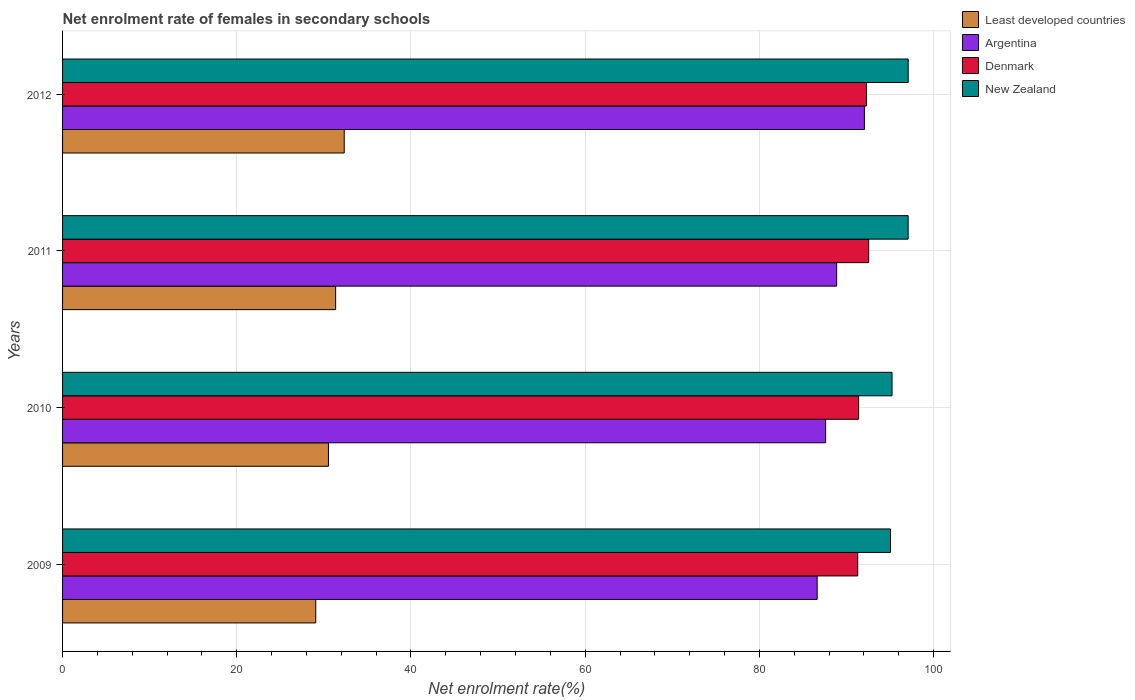How many different coloured bars are there?
Ensure brevity in your answer.  4. How many groups of bars are there?
Offer a very short reply. 4. Are the number of bars per tick equal to the number of legend labels?
Your answer should be very brief. Yes. How many bars are there on the 1st tick from the bottom?
Offer a terse response. 4. What is the label of the 1st group of bars from the top?
Offer a very short reply. 2012. What is the net enrolment rate of females in secondary schools in Least developed countries in 2010?
Give a very brief answer. 30.53. Across all years, what is the maximum net enrolment rate of females in secondary schools in New Zealand?
Your answer should be very brief. 97.09. Across all years, what is the minimum net enrolment rate of females in secondary schools in Argentina?
Give a very brief answer. 86.64. In which year was the net enrolment rate of females in secondary schools in Denmark maximum?
Your response must be concise. 2011. What is the total net enrolment rate of females in secondary schools in Denmark in the graph?
Provide a short and direct response. 367.52. What is the difference between the net enrolment rate of females in secondary schools in Denmark in 2009 and that in 2012?
Your answer should be very brief. -1. What is the difference between the net enrolment rate of females in secondary schools in Least developed countries in 2010 and the net enrolment rate of females in secondary schools in New Zealand in 2011?
Your response must be concise. -66.55. What is the average net enrolment rate of females in secondary schools in Least developed countries per year?
Provide a succinct answer. 30.82. In the year 2012, what is the difference between the net enrolment rate of females in secondary schools in Argentina and net enrolment rate of females in secondary schools in New Zealand?
Your answer should be compact. -5.03. In how many years, is the net enrolment rate of females in secondary schools in Least developed countries greater than 96 %?
Provide a succinct answer. 0. What is the ratio of the net enrolment rate of females in secondary schools in Least developed countries in 2009 to that in 2010?
Your response must be concise. 0.95. Is the difference between the net enrolment rate of females in secondary schools in Argentina in 2009 and 2011 greater than the difference between the net enrolment rate of females in secondary schools in New Zealand in 2009 and 2011?
Your answer should be very brief. No. What is the difference between the highest and the second highest net enrolment rate of females in secondary schools in Argentina?
Provide a succinct answer. 3.19. What is the difference between the highest and the lowest net enrolment rate of females in secondary schools in Denmark?
Provide a short and direct response. 1.26. Is the sum of the net enrolment rate of females in secondary schools in Denmark in 2009 and 2012 greater than the maximum net enrolment rate of females in secondary schools in New Zealand across all years?
Keep it short and to the point. Yes. Is it the case that in every year, the sum of the net enrolment rate of females in secondary schools in Denmark and net enrolment rate of females in secondary schools in Argentina is greater than the sum of net enrolment rate of females in secondary schools in New Zealand and net enrolment rate of females in secondary schools in Least developed countries?
Your answer should be compact. No. What does the 4th bar from the top in 2010 represents?
Keep it short and to the point. Least developed countries. Is it the case that in every year, the sum of the net enrolment rate of females in secondary schools in Denmark and net enrolment rate of females in secondary schools in New Zealand is greater than the net enrolment rate of females in secondary schools in Argentina?
Give a very brief answer. Yes. How many bars are there?
Provide a short and direct response. 16. What is the difference between two consecutive major ticks on the X-axis?
Ensure brevity in your answer.  20. Does the graph contain grids?
Offer a very short reply. Yes. Where does the legend appear in the graph?
Give a very brief answer. Top right. How many legend labels are there?
Provide a short and direct response. 4. What is the title of the graph?
Your answer should be very brief. Net enrolment rate of females in secondary schools. What is the label or title of the X-axis?
Ensure brevity in your answer.  Net enrolment rate(%). What is the Net enrolment rate(%) in Least developed countries in 2009?
Give a very brief answer. 29.07. What is the Net enrolment rate(%) in Argentina in 2009?
Provide a short and direct response. 86.64. What is the Net enrolment rate(%) of Denmark in 2009?
Your answer should be compact. 91.29. What is the Net enrolment rate(%) in New Zealand in 2009?
Your answer should be very brief. 95.05. What is the Net enrolment rate(%) of Least developed countries in 2010?
Offer a terse response. 30.53. What is the Net enrolment rate(%) in Argentina in 2010?
Offer a terse response. 87.61. What is the Net enrolment rate(%) of Denmark in 2010?
Provide a short and direct response. 91.39. What is the Net enrolment rate(%) in New Zealand in 2010?
Provide a succinct answer. 95.23. What is the Net enrolment rate(%) of Least developed countries in 2011?
Your answer should be compact. 31.35. What is the Net enrolment rate(%) of Argentina in 2011?
Make the answer very short. 88.87. What is the Net enrolment rate(%) of Denmark in 2011?
Give a very brief answer. 92.55. What is the Net enrolment rate(%) in New Zealand in 2011?
Offer a terse response. 97.08. What is the Net enrolment rate(%) of Least developed countries in 2012?
Offer a terse response. 32.34. What is the Net enrolment rate(%) of Argentina in 2012?
Your answer should be very brief. 92.06. What is the Net enrolment rate(%) in Denmark in 2012?
Offer a very short reply. 92.29. What is the Net enrolment rate(%) in New Zealand in 2012?
Offer a terse response. 97.09. Across all years, what is the maximum Net enrolment rate(%) of Least developed countries?
Make the answer very short. 32.34. Across all years, what is the maximum Net enrolment rate(%) in Argentina?
Offer a very short reply. 92.06. Across all years, what is the maximum Net enrolment rate(%) of Denmark?
Offer a terse response. 92.55. Across all years, what is the maximum Net enrolment rate(%) of New Zealand?
Give a very brief answer. 97.09. Across all years, what is the minimum Net enrolment rate(%) of Least developed countries?
Provide a short and direct response. 29.07. Across all years, what is the minimum Net enrolment rate(%) of Argentina?
Ensure brevity in your answer.  86.64. Across all years, what is the minimum Net enrolment rate(%) of Denmark?
Provide a short and direct response. 91.29. Across all years, what is the minimum Net enrolment rate(%) in New Zealand?
Give a very brief answer. 95.05. What is the total Net enrolment rate(%) of Least developed countries in the graph?
Keep it short and to the point. 123.28. What is the total Net enrolment rate(%) in Argentina in the graph?
Your response must be concise. 355.18. What is the total Net enrolment rate(%) of Denmark in the graph?
Provide a short and direct response. 367.52. What is the total Net enrolment rate(%) of New Zealand in the graph?
Make the answer very short. 384.45. What is the difference between the Net enrolment rate(%) of Least developed countries in 2009 and that in 2010?
Keep it short and to the point. -1.46. What is the difference between the Net enrolment rate(%) of Argentina in 2009 and that in 2010?
Your answer should be compact. -0.97. What is the difference between the Net enrolment rate(%) of Denmark in 2009 and that in 2010?
Make the answer very short. -0.1. What is the difference between the Net enrolment rate(%) in New Zealand in 2009 and that in 2010?
Offer a very short reply. -0.18. What is the difference between the Net enrolment rate(%) in Least developed countries in 2009 and that in 2011?
Ensure brevity in your answer.  -2.28. What is the difference between the Net enrolment rate(%) of Argentina in 2009 and that in 2011?
Provide a succinct answer. -2.24. What is the difference between the Net enrolment rate(%) of Denmark in 2009 and that in 2011?
Provide a succinct answer. -1.26. What is the difference between the Net enrolment rate(%) of New Zealand in 2009 and that in 2011?
Your response must be concise. -2.03. What is the difference between the Net enrolment rate(%) in Least developed countries in 2009 and that in 2012?
Your answer should be very brief. -3.27. What is the difference between the Net enrolment rate(%) in Argentina in 2009 and that in 2012?
Offer a terse response. -5.42. What is the difference between the Net enrolment rate(%) of Denmark in 2009 and that in 2012?
Give a very brief answer. -1. What is the difference between the Net enrolment rate(%) of New Zealand in 2009 and that in 2012?
Ensure brevity in your answer.  -2.03. What is the difference between the Net enrolment rate(%) in Least developed countries in 2010 and that in 2011?
Make the answer very short. -0.83. What is the difference between the Net enrolment rate(%) in Argentina in 2010 and that in 2011?
Offer a terse response. -1.26. What is the difference between the Net enrolment rate(%) in Denmark in 2010 and that in 2011?
Your answer should be compact. -1.16. What is the difference between the Net enrolment rate(%) of New Zealand in 2010 and that in 2011?
Provide a short and direct response. -1.85. What is the difference between the Net enrolment rate(%) in Least developed countries in 2010 and that in 2012?
Your response must be concise. -1.81. What is the difference between the Net enrolment rate(%) in Argentina in 2010 and that in 2012?
Give a very brief answer. -4.45. What is the difference between the Net enrolment rate(%) in Denmark in 2010 and that in 2012?
Provide a succinct answer. -0.9. What is the difference between the Net enrolment rate(%) in New Zealand in 2010 and that in 2012?
Ensure brevity in your answer.  -1.85. What is the difference between the Net enrolment rate(%) in Least developed countries in 2011 and that in 2012?
Offer a terse response. -0.99. What is the difference between the Net enrolment rate(%) of Argentina in 2011 and that in 2012?
Make the answer very short. -3.19. What is the difference between the Net enrolment rate(%) of Denmark in 2011 and that in 2012?
Provide a succinct answer. 0.26. What is the difference between the Net enrolment rate(%) in New Zealand in 2011 and that in 2012?
Offer a terse response. -0.01. What is the difference between the Net enrolment rate(%) in Least developed countries in 2009 and the Net enrolment rate(%) in Argentina in 2010?
Your answer should be very brief. -58.54. What is the difference between the Net enrolment rate(%) in Least developed countries in 2009 and the Net enrolment rate(%) in Denmark in 2010?
Ensure brevity in your answer.  -62.32. What is the difference between the Net enrolment rate(%) in Least developed countries in 2009 and the Net enrolment rate(%) in New Zealand in 2010?
Provide a short and direct response. -66.16. What is the difference between the Net enrolment rate(%) of Argentina in 2009 and the Net enrolment rate(%) of Denmark in 2010?
Provide a short and direct response. -4.76. What is the difference between the Net enrolment rate(%) in Argentina in 2009 and the Net enrolment rate(%) in New Zealand in 2010?
Give a very brief answer. -8.6. What is the difference between the Net enrolment rate(%) of Denmark in 2009 and the Net enrolment rate(%) of New Zealand in 2010?
Offer a terse response. -3.94. What is the difference between the Net enrolment rate(%) in Least developed countries in 2009 and the Net enrolment rate(%) in Argentina in 2011?
Provide a succinct answer. -59.8. What is the difference between the Net enrolment rate(%) in Least developed countries in 2009 and the Net enrolment rate(%) in Denmark in 2011?
Offer a terse response. -63.48. What is the difference between the Net enrolment rate(%) in Least developed countries in 2009 and the Net enrolment rate(%) in New Zealand in 2011?
Provide a succinct answer. -68.01. What is the difference between the Net enrolment rate(%) in Argentina in 2009 and the Net enrolment rate(%) in Denmark in 2011?
Offer a very short reply. -5.91. What is the difference between the Net enrolment rate(%) in Argentina in 2009 and the Net enrolment rate(%) in New Zealand in 2011?
Provide a succinct answer. -10.44. What is the difference between the Net enrolment rate(%) in Denmark in 2009 and the Net enrolment rate(%) in New Zealand in 2011?
Provide a short and direct response. -5.79. What is the difference between the Net enrolment rate(%) of Least developed countries in 2009 and the Net enrolment rate(%) of Argentina in 2012?
Your answer should be very brief. -62.99. What is the difference between the Net enrolment rate(%) in Least developed countries in 2009 and the Net enrolment rate(%) in Denmark in 2012?
Make the answer very short. -63.22. What is the difference between the Net enrolment rate(%) in Least developed countries in 2009 and the Net enrolment rate(%) in New Zealand in 2012?
Provide a short and direct response. -68.02. What is the difference between the Net enrolment rate(%) of Argentina in 2009 and the Net enrolment rate(%) of Denmark in 2012?
Make the answer very short. -5.66. What is the difference between the Net enrolment rate(%) of Argentina in 2009 and the Net enrolment rate(%) of New Zealand in 2012?
Give a very brief answer. -10.45. What is the difference between the Net enrolment rate(%) in Denmark in 2009 and the Net enrolment rate(%) in New Zealand in 2012?
Ensure brevity in your answer.  -5.8. What is the difference between the Net enrolment rate(%) of Least developed countries in 2010 and the Net enrolment rate(%) of Argentina in 2011?
Provide a succinct answer. -58.35. What is the difference between the Net enrolment rate(%) of Least developed countries in 2010 and the Net enrolment rate(%) of Denmark in 2011?
Provide a short and direct response. -62.02. What is the difference between the Net enrolment rate(%) of Least developed countries in 2010 and the Net enrolment rate(%) of New Zealand in 2011?
Your response must be concise. -66.56. What is the difference between the Net enrolment rate(%) of Argentina in 2010 and the Net enrolment rate(%) of Denmark in 2011?
Keep it short and to the point. -4.94. What is the difference between the Net enrolment rate(%) of Argentina in 2010 and the Net enrolment rate(%) of New Zealand in 2011?
Provide a succinct answer. -9.47. What is the difference between the Net enrolment rate(%) of Denmark in 2010 and the Net enrolment rate(%) of New Zealand in 2011?
Your answer should be compact. -5.69. What is the difference between the Net enrolment rate(%) in Least developed countries in 2010 and the Net enrolment rate(%) in Argentina in 2012?
Make the answer very short. -61.53. What is the difference between the Net enrolment rate(%) of Least developed countries in 2010 and the Net enrolment rate(%) of Denmark in 2012?
Offer a terse response. -61.77. What is the difference between the Net enrolment rate(%) in Least developed countries in 2010 and the Net enrolment rate(%) in New Zealand in 2012?
Make the answer very short. -66.56. What is the difference between the Net enrolment rate(%) of Argentina in 2010 and the Net enrolment rate(%) of Denmark in 2012?
Provide a succinct answer. -4.68. What is the difference between the Net enrolment rate(%) of Argentina in 2010 and the Net enrolment rate(%) of New Zealand in 2012?
Provide a succinct answer. -9.48. What is the difference between the Net enrolment rate(%) in Denmark in 2010 and the Net enrolment rate(%) in New Zealand in 2012?
Offer a terse response. -5.69. What is the difference between the Net enrolment rate(%) in Least developed countries in 2011 and the Net enrolment rate(%) in Argentina in 2012?
Your response must be concise. -60.71. What is the difference between the Net enrolment rate(%) in Least developed countries in 2011 and the Net enrolment rate(%) in Denmark in 2012?
Your answer should be very brief. -60.94. What is the difference between the Net enrolment rate(%) in Least developed countries in 2011 and the Net enrolment rate(%) in New Zealand in 2012?
Offer a terse response. -65.74. What is the difference between the Net enrolment rate(%) in Argentina in 2011 and the Net enrolment rate(%) in Denmark in 2012?
Provide a short and direct response. -3.42. What is the difference between the Net enrolment rate(%) in Argentina in 2011 and the Net enrolment rate(%) in New Zealand in 2012?
Offer a very short reply. -8.21. What is the difference between the Net enrolment rate(%) of Denmark in 2011 and the Net enrolment rate(%) of New Zealand in 2012?
Offer a very short reply. -4.54. What is the average Net enrolment rate(%) of Least developed countries per year?
Your answer should be compact. 30.82. What is the average Net enrolment rate(%) in Argentina per year?
Offer a terse response. 88.79. What is the average Net enrolment rate(%) of Denmark per year?
Your answer should be compact. 91.88. What is the average Net enrolment rate(%) in New Zealand per year?
Offer a terse response. 96.11. In the year 2009, what is the difference between the Net enrolment rate(%) of Least developed countries and Net enrolment rate(%) of Argentina?
Your answer should be compact. -57.57. In the year 2009, what is the difference between the Net enrolment rate(%) in Least developed countries and Net enrolment rate(%) in Denmark?
Provide a succinct answer. -62.22. In the year 2009, what is the difference between the Net enrolment rate(%) of Least developed countries and Net enrolment rate(%) of New Zealand?
Provide a succinct answer. -65.98. In the year 2009, what is the difference between the Net enrolment rate(%) of Argentina and Net enrolment rate(%) of Denmark?
Give a very brief answer. -4.65. In the year 2009, what is the difference between the Net enrolment rate(%) in Argentina and Net enrolment rate(%) in New Zealand?
Make the answer very short. -8.42. In the year 2009, what is the difference between the Net enrolment rate(%) in Denmark and Net enrolment rate(%) in New Zealand?
Provide a succinct answer. -3.76. In the year 2010, what is the difference between the Net enrolment rate(%) of Least developed countries and Net enrolment rate(%) of Argentina?
Make the answer very short. -57.08. In the year 2010, what is the difference between the Net enrolment rate(%) of Least developed countries and Net enrolment rate(%) of Denmark?
Keep it short and to the point. -60.87. In the year 2010, what is the difference between the Net enrolment rate(%) in Least developed countries and Net enrolment rate(%) in New Zealand?
Your answer should be very brief. -64.71. In the year 2010, what is the difference between the Net enrolment rate(%) of Argentina and Net enrolment rate(%) of Denmark?
Your response must be concise. -3.78. In the year 2010, what is the difference between the Net enrolment rate(%) of Argentina and Net enrolment rate(%) of New Zealand?
Your answer should be very brief. -7.62. In the year 2010, what is the difference between the Net enrolment rate(%) of Denmark and Net enrolment rate(%) of New Zealand?
Your answer should be compact. -3.84. In the year 2011, what is the difference between the Net enrolment rate(%) of Least developed countries and Net enrolment rate(%) of Argentina?
Offer a very short reply. -57.52. In the year 2011, what is the difference between the Net enrolment rate(%) in Least developed countries and Net enrolment rate(%) in Denmark?
Give a very brief answer. -61.2. In the year 2011, what is the difference between the Net enrolment rate(%) in Least developed countries and Net enrolment rate(%) in New Zealand?
Provide a short and direct response. -65.73. In the year 2011, what is the difference between the Net enrolment rate(%) of Argentina and Net enrolment rate(%) of Denmark?
Ensure brevity in your answer.  -3.68. In the year 2011, what is the difference between the Net enrolment rate(%) in Argentina and Net enrolment rate(%) in New Zealand?
Your response must be concise. -8.21. In the year 2011, what is the difference between the Net enrolment rate(%) in Denmark and Net enrolment rate(%) in New Zealand?
Offer a terse response. -4.53. In the year 2012, what is the difference between the Net enrolment rate(%) of Least developed countries and Net enrolment rate(%) of Argentina?
Give a very brief answer. -59.72. In the year 2012, what is the difference between the Net enrolment rate(%) in Least developed countries and Net enrolment rate(%) in Denmark?
Provide a succinct answer. -59.95. In the year 2012, what is the difference between the Net enrolment rate(%) of Least developed countries and Net enrolment rate(%) of New Zealand?
Keep it short and to the point. -64.75. In the year 2012, what is the difference between the Net enrolment rate(%) of Argentina and Net enrolment rate(%) of Denmark?
Provide a succinct answer. -0.23. In the year 2012, what is the difference between the Net enrolment rate(%) of Argentina and Net enrolment rate(%) of New Zealand?
Keep it short and to the point. -5.03. In the year 2012, what is the difference between the Net enrolment rate(%) of Denmark and Net enrolment rate(%) of New Zealand?
Your response must be concise. -4.8. What is the ratio of the Net enrolment rate(%) in Least developed countries in 2009 to that in 2010?
Provide a succinct answer. 0.95. What is the ratio of the Net enrolment rate(%) in Argentina in 2009 to that in 2010?
Provide a succinct answer. 0.99. What is the ratio of the Net enrolment rate(%) of Denmark in 2009 to that in 2010?
Make the answer very short. 1. What is the ratio of the Net enrolment rate(%) in Least developed countries in 2009 to that in 2011?
Offer a very short reply. 0.93. What is the ratio of the Net enrolment rate(%) in Argentina in 2009 to that in 2011?
Keep it short and to the point. 0.97. What is the ratio of the Net enrolment rate(%) of Denmark in 2009 to that in 2011?
Ensure brevity in your answer.  0.99. What is the ratio of the Net enrolment rate(%) in New Zealand in 2009 to that in 2011?
Keep it short and to the point. 0.98. What is the ratio of the Net enrolment rate(%) in Least developed countries in 2009 to that in 2012?
Provide a short and direct response. 0.9. What is the ratio of the Net enrolment rate(%) of Argentina in 2009 to that in 2012?
Make the answer very short. 0.94. What is the ratio of the Net enrolment rate(%) of Least developed countries in 2010 to that in 2011?
Give a very brief answer. 0.97. What is the ratio of the Net enrolment rate(%) in Argentina in 2010 to that in 2011?
Make the answer very short. 0.99. What is the ratio of the Net enrolment rate(%) in Denmark in 2010 to that in 2011?
Your answer should be very brief. 0.99. What is the ratio of the Net enrolment rate(%) of New Zealand in 2010 to that in 2011?
Offer a very short reply. 0.98. What is the ratio of the Net enrolment rate(%) in Least developed countries in 2010 to that in 2012?
Make the answer very short. 0.94. What is the ratio of the Net enrolment rate(%) in Argentina in 2010 to that in 2012?
Make the answer very short. 0.95. What is the ratio of the Net enrolment rate(%) of Denmark in 2010 to that in 2012?
Provide a succinct answer. 0.99. What is the ratio of the Net enrolment rate(%) in New Zealand in 2010 to that in 2012?
Your answer should be very brief. 0.98. What is the ratio of the Net enrolment rate(%) in Least developed countries in 2011 to that in 2012?
Ensure brevity in your answer.  0.97. What is the ratio of the Net enrolment rate(%) of Argentina in 2011 to that in 2012?
Your answer should be compact. 0.97. What is the ratio of the Net enrolment rate(%) of New Zealand in 2011 to that in 2012?
Offer a very short reply. 1. What is the difference between the highest and the second highest Net enrolment rate(%) of Least developed countries?
Offer a very short reply. 0.99. What is the difference between the highest and the second highest Net enrolment rate(%) of Argentina?
Provide a short and direct response. 3.19. What is the difference between the highest and the second highest Net enrolment rate(%) in Denmark?
Keep it short and to the point. 0.26. What is the difference between the highest and the second highest Net enrolment rate(%) of New Zealand?
Give a very brief answer. 0.01. What is the difference between the highest and the lowest Net enrolment rate(%) of Least developed countries?
Your response must be concise. 3.27. What is the difference between the highest and the lowest Net enrolment rate(%) of Argentina?
Provide a short and direct response. 5.42. What is the difference between the highest and the lowest Net enrolment rate(%) of Denmark?
Provide a short and direct response. 1.26. What is the difference between the highest and the lowest Net enrolment rate(%) in New Zealand?
Offer a very short reply. 2.03. 